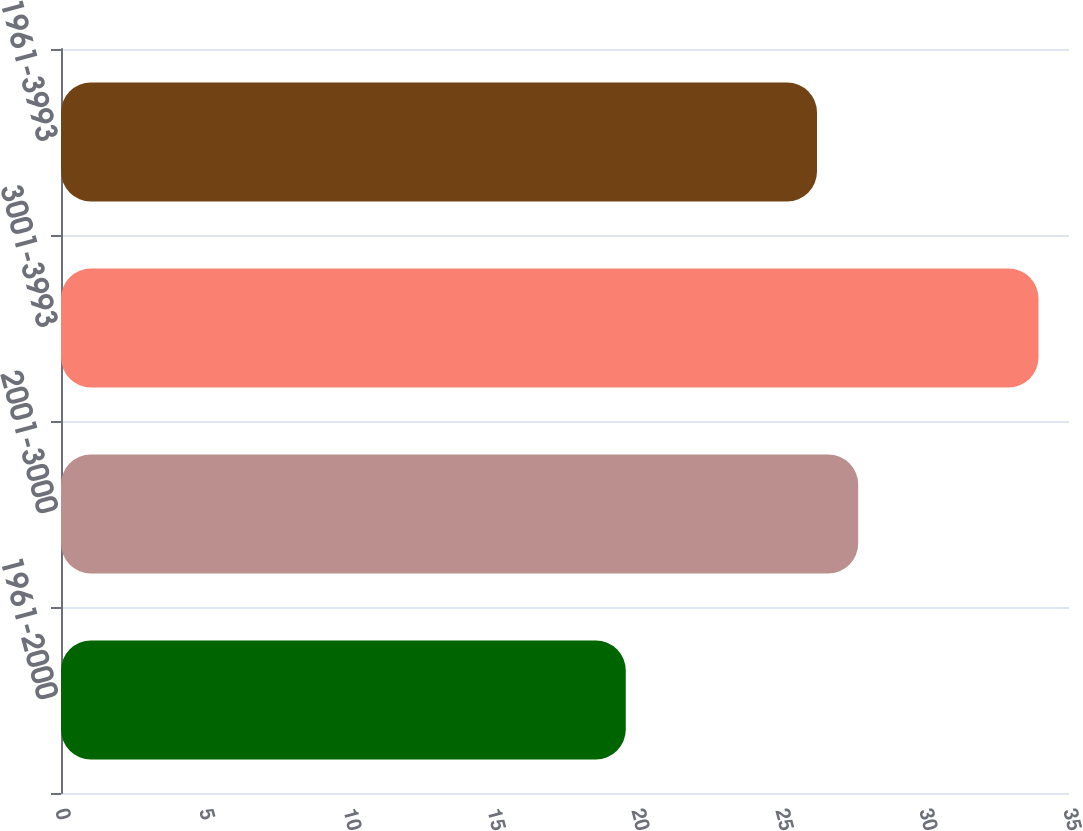Convert chart. <chart><loc_0><loc_0><loc_500><loc_500><bar_chart><fcel>1961-2000<fcel>2001-3000<fcel>3001-3993<fcel>1961-3993<nl><fcel>19.61<fcel>27.68<fcel>33.94<fcel>26.25<nl></chart> 